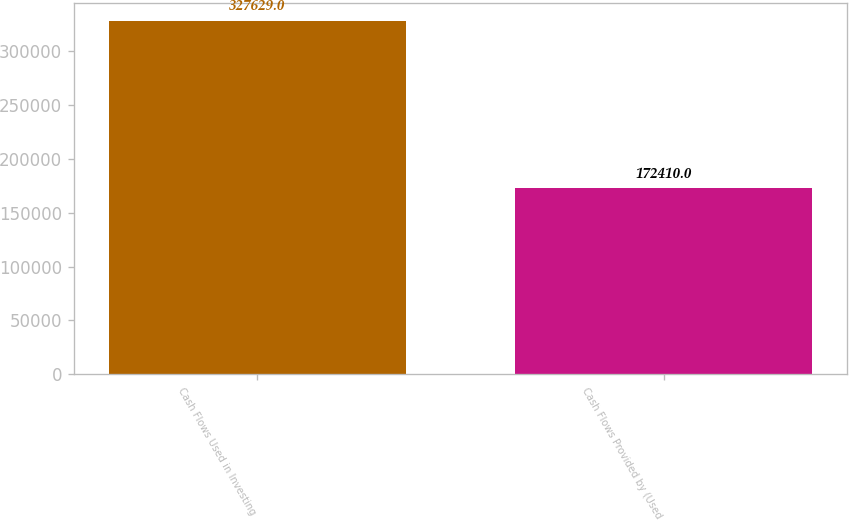Convert chart. <chart><loc_0><loc_0><loc_500><loc_500><bar_chart><fcel>Cash Flows Used in Investing<fcel>Cash Flows Provided by (Used<nl><fcel>327629<fcel>172410<nl></chart> 